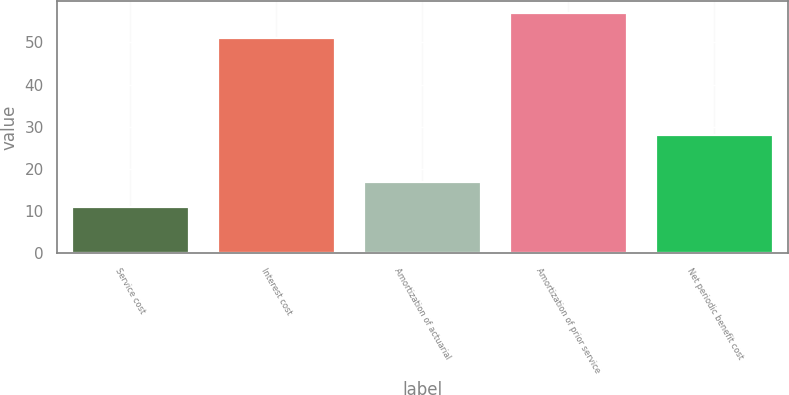<chart> <loc_0><loc_0><loc_500><loc_500><bar_chart><fcel>Service cost<fcel>Interest cost<fcel>Amortization of actuarial<fcel>Amortization of prior service<fcel>Net periodic benefit cost<nl><fcel>11<fcel>51<fcel>17<fcel>57<fcel>28<nl></chart> 